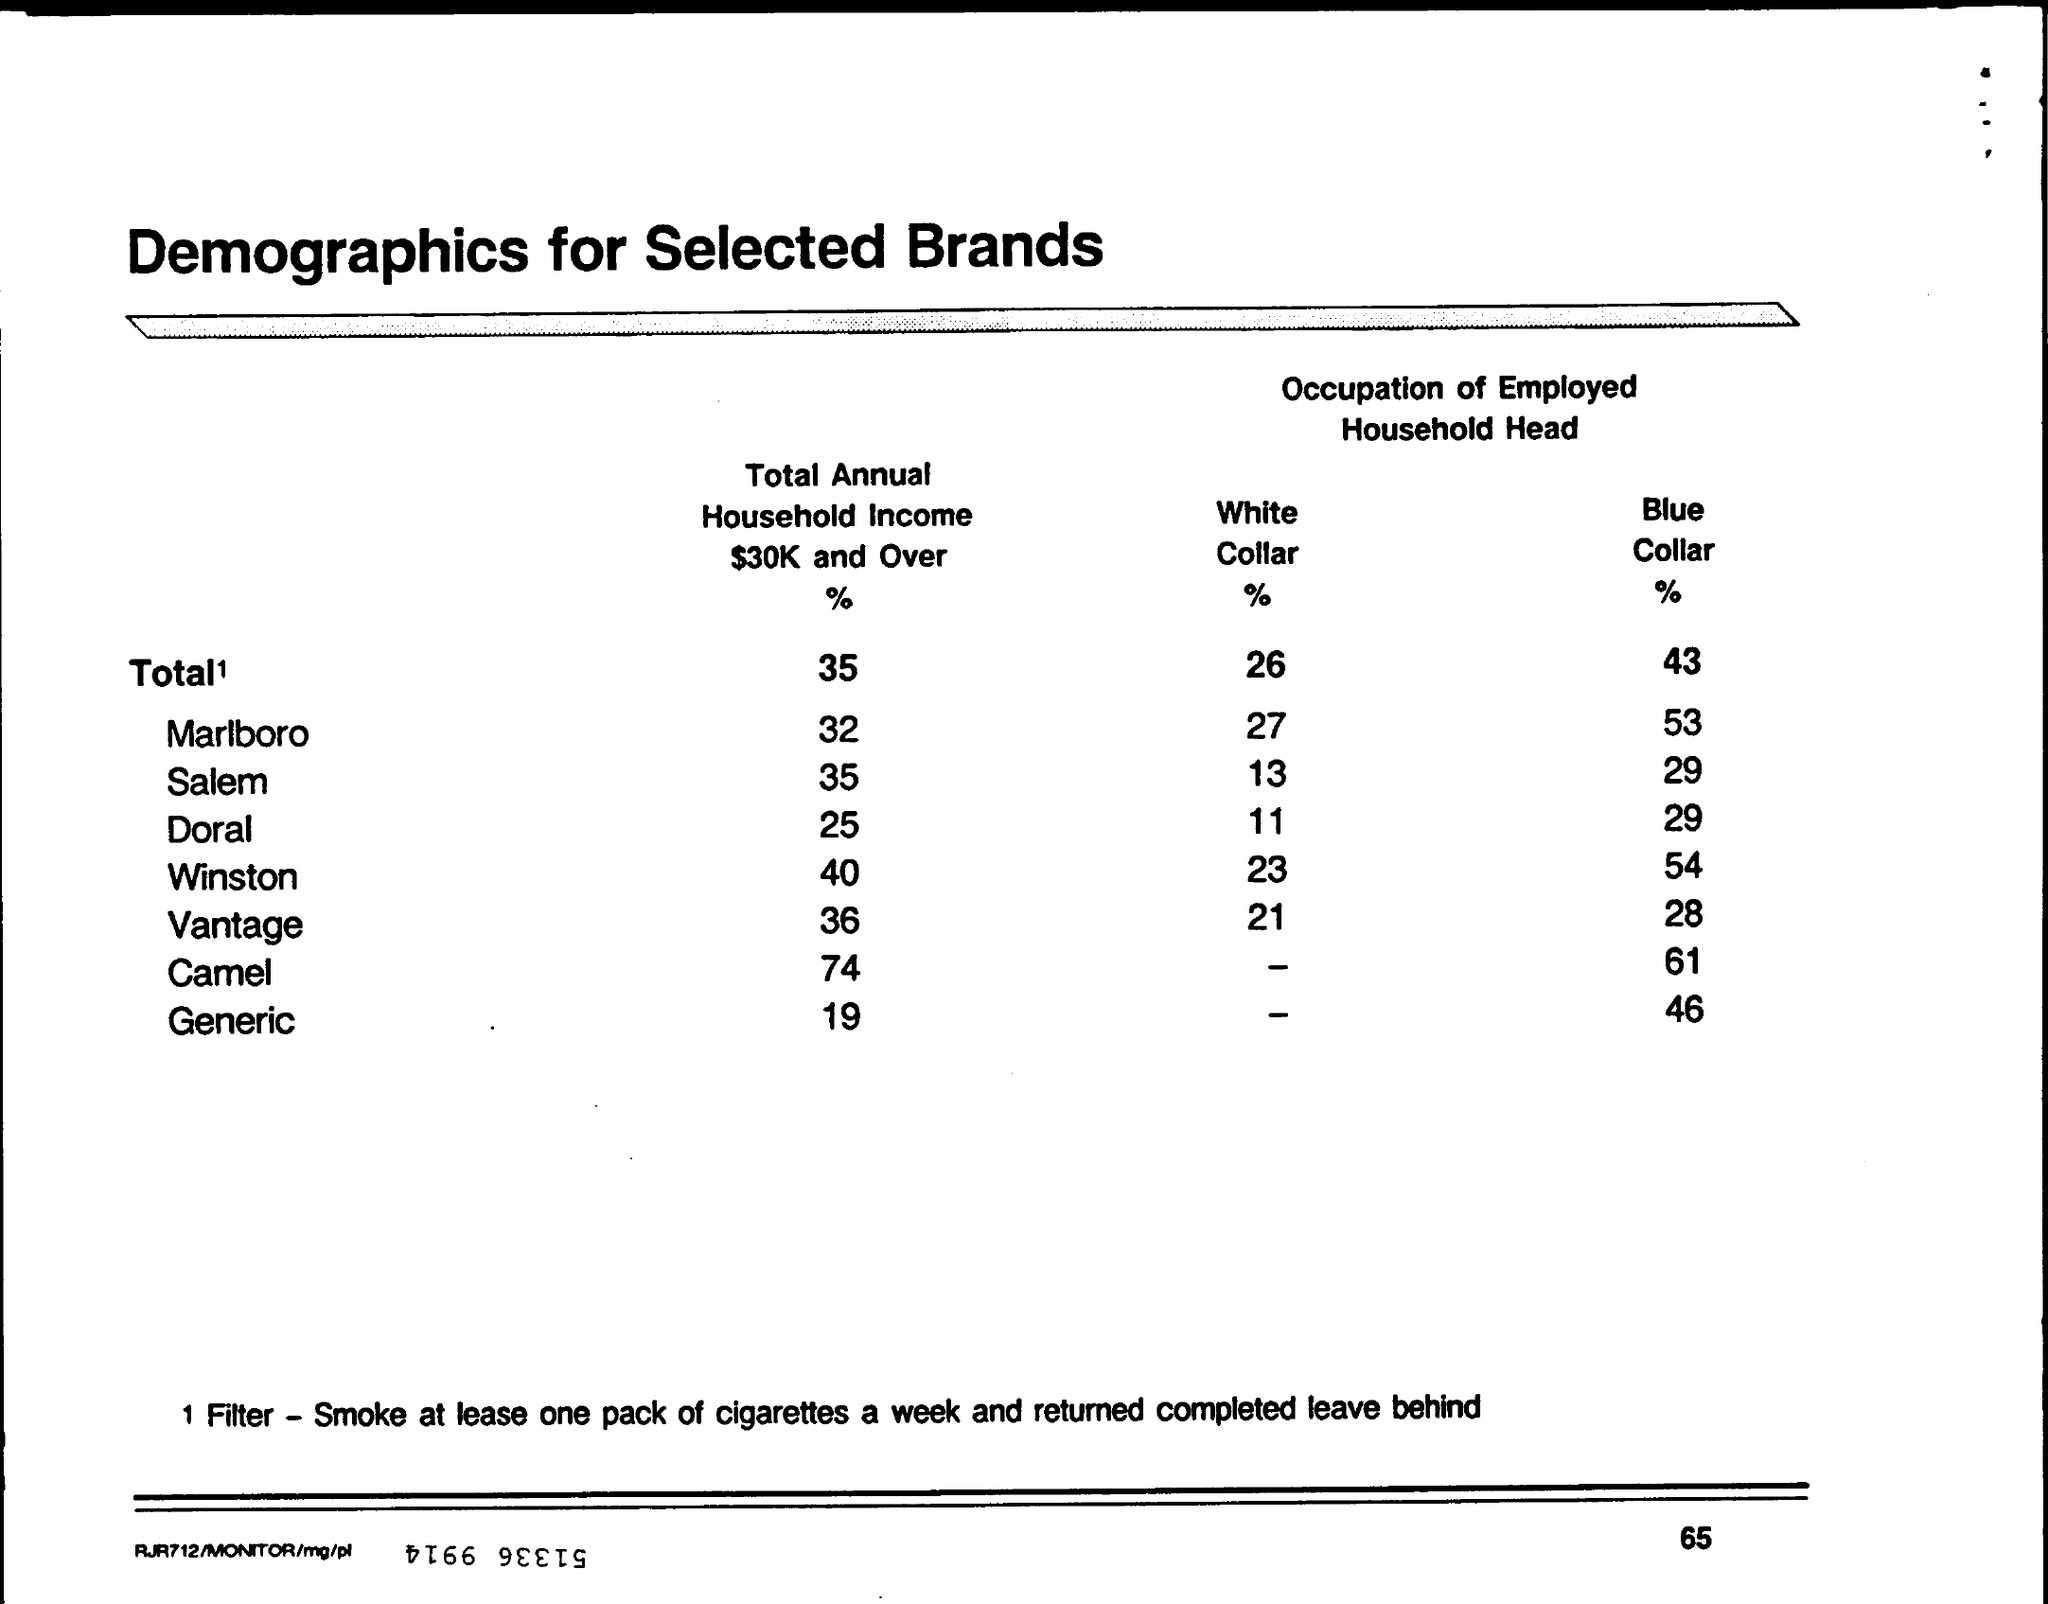What is the title of the table?
Your answer should be compact. Demographics for Selected Brands. What percentage of people with Total Annual Household Income $30K and Over used Vantage?
Provide a short and direct response. 36. 